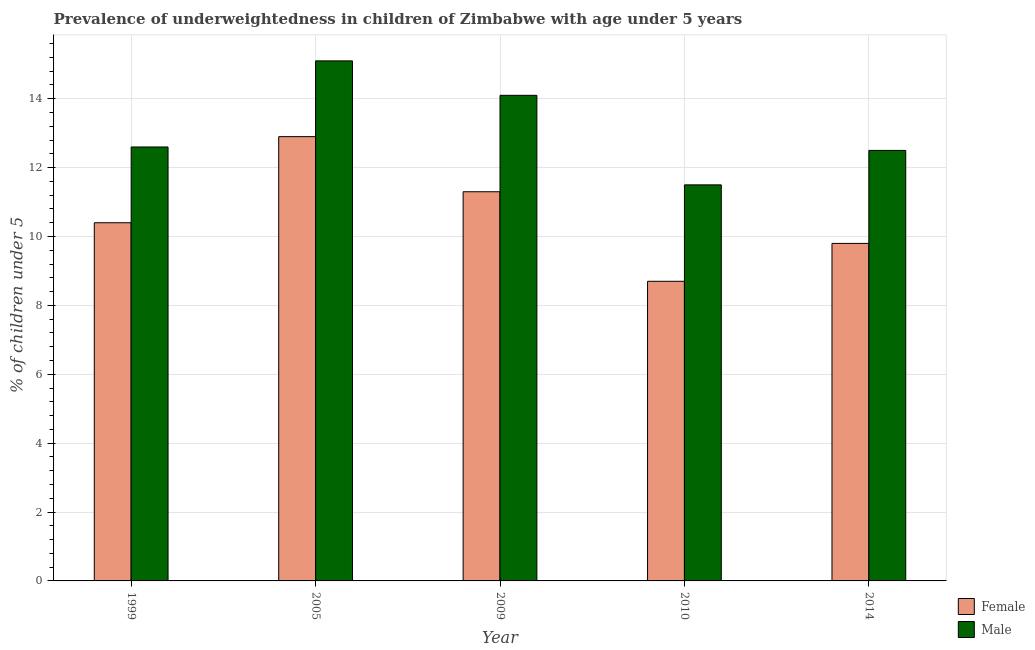Are the number of bars per tick equal to the number of legend labels?
Give a very brief answer. Yes. What is the label of the 3rd group of bars from the left?
Give a very brief answer. 2009. What is the percentage of underweighted female children in 2009?
Offer a very short reply. 11.3. Across all years, what is the maximum percentage of underweighted female children?
Offer a very short reply. 12.9. Across all years, what is the minimum percentage of underweighted female children?
Ensure brevity in your answer.  8.7. What is the total percentage of underweighted female children in the graph?
Make the answer very short. 53.1. What is the difference between the percentage of underweighted female children in 2005 and that in 2014?
Offer a very short reply. 3.1. What is the average percentage of underweighted female children per year?
Provide a short and direct response. 10.62. What is the ratio of the percentage of underweighted male children in 2009 to that in 2014?
Provide a succinct answer. 1.13. What is the difference between the highest and the lowest percentage of underweighted male children?
Your response must be concise. 3.6. In how many years, is the percentage of underweighted female children greater than the average percentage of underweighted female children taken over all years?
Keep it short and to the point. 2. Is the sum of the percentage of underweighted male children in 1999 and 2009 greater than the maximum percentage of underweighted female children across all years?
Make the answer very short. Yes. What does the 1st bar from the left in 1999 represents?
Ensure brevity in your answer.  Female. How many bars are there?
Your response must be concise. 10. Are all the bars in the graph horizontal?
Your answer should be compact. No. Does the graph contain grids?
Give a very brief answer. Yes. Where does the legend appear in the graph?
Ensure brevity in your answer.  Bottom right. How many legend labels are there?
Keep it short and to the point. 2. What is the title of the graph?
Provide a short and direct response. Prevalence of underweightedness in children of Zimbabwe with age under 5 years. What is the label or title of the Y-axis?
Offer a terse response.  % of children under 5. What is the  % of children under 5 of Female in 1999?
Provide a short and direct response. 10.4. What is the  % of children under 5 of Male in 1999?
Your response must be concise. 12.6. What is the  % of children under 5 of Female in 2005?
Keep it short and to the point. 12.9. What is the  % of children under 5 of Male in 2005?
Make the answer very short. 15.1. What is the  % of children under 5 in Female in 2009?
Provide a succinct answer. 11.3. What is the  % of children under 5 in Male in 2009?
Offer a very short reply. 14.1. What is the  % of children under 5 of Female in 2010?
Your answer should be compact. 8.7. What is the  % of children under 5 of Female in 2014?
Offer a terse response. 9.8. Across all years, what is the maximum  % of children under 5 in Female?
Provide a short and direct response. 12.9. Across all years, what is the maximum  % of children under 5 in Male?
Your response must be concise. 15.1. Across all years, what is the minimum  % of children under 5 of Female?
Give a very brief answer. 8.7. What is the total  % of children under 5 in Female in the graph?
Keep it short and to the point. 53.1. What is the total  % of children under 5 of Male in the graph?
Offer a very short reply. 65.8. What is the difference between the  % of children under 5 of Female in 1999 and that in 2005?
Your answer should be compact. -2.5. What is the difference between the  % of children under 5 in Male in 1999 and that in 2005?
Your answer should be very brief. -2.5. What is the difference between the  % of children under 5 in Female in 1999 and that in 2009?
Provide a succinct answer. -0.9. What is the difference between the  % of children under 5 of Male in 1999 and that in 2009?
Give a very brief answer. -1.5. What is the difference between the  % of children under 5 in Female in 1999 and that in 2014?
Ensure brevity in your answer.  0.6. What is the difference between the  % of children under 5 of Female in 2005 and that in 2009?
Provide a short and direct response. 1.6. What is the difference between the  % of children under 5 of Male in 2005 and that in 2009?
Your answer should be very brief. 1. What is the difference between the  % of children under 5 in Female in 2005 and that in 2010?
Your response must be concise. 4.2. What is the difference between the  % of children under 5 of Male in 2005 and that in 2010?
Offer a terse response. 3.6. What is the difference between the  % of children under 5 of Female in 2005 and that in 2014?
Give a very brief answer. 3.1. What is the difference between the  % of children under 5 in Male in 2005 and that in 2014?
Ensure brevity in your answer.  2.6. What is the difference between the  % of children under 5 in Female in 2009 and that in 2010?
Give a very brief answer. 2.6. What is the difference between the  % of children under 5 in Male in 2009 and that in 2010?
Ensure brevity in your answer.  2.6. What is the difference between the  % of children under 5 in Female in 2009 and that in 2014?
Offer a very short reply. 1.5. What is the difference between the  % of children under 5 in Male in 2009 and that in 2014?
Your answer should be very brief. 1.6. What is the difference between the  % of children under 5 of Male in 2010 and that in 2014?
Keep it short and to the point. -1. What is the difference between the  % of children under 5 in Female in 1999 and the  % of children under 5 in Male in 2005?
Offer a very short reply. -4.7. What is the difference between the  % of children under 5 in Female in 1999 and the  % of children under 5 in Male in 2010?
Offer a very short reply. -1.1. What is the difference between the  % of children under 5 in Female in 2005 and the  % of children under 5 in Male in 2010?
Your answer should be very brief. 1.4. What is the difference between the  % of children under 5 of Female in 2005 and the  % of children under 5 of Male in 2014?
Offer a very short reply. 0.4. What is the difference between the  % of children under 5 of Female in 2010 and the  % of children under 5 of Male in 2014?
Offer a very short reply. -3.8. What is the average  % of children under 5 in Female per year?
Offer a very short reply. 10.62. What is the average  % of children under 5 in Male per year?
Make the answer very short. 13.16. In the year 2005, what is the difference between the  % of children under 5 of Female and  % of children under 5 of Male?
Make the answer very short. -2.2. In the year 2009, what is the difference between the  % of children under 5 in Female and  % of children under 5 in Male?
Provide a short and direct response. -2.8. In the year 2010, what is the difference between the  % of children under 5 in Female and  % of children under 5 in Male?
Offer a very short reply. -2.8. In the year 2014, what is the difference between the  % of children under 5 of Female and  % of children under 5 of Male?
Provide a short and direct response. -2.7. What is the ratio of the  % of children under 5 in Female in 1999 to that in 2005?
Offer a terse response. 0.81. What is the ratio of the  % of children under 5 in Male in 1999 to that in 2005?
Offer a terse response. 0.83. What is the ratio of the  % of children under 5 of Female in 1999 to that in 2009?
Keep it short and to the point. 0.92. What is the ratio of the  % of children under 5 in Male in 1999 to that in 2009?
Keep it short and to the point. 0.89. What is the ratio of the  % of children under 5 of Female in 1999 to that in 2010?
Give a very brief answer. 1.2. What is the ratio of the  % of children under 5 of Male in 1999 to that in 2010?
Offer a terse response. 1.1. What is the ratio of the  % of children under 5 of Female in 1999 to that in 2014?
Offer a very short reply. 1.06. What is the ratio of the  % of children under 5 in Male in 1999 to that in 2014?
Offer a terse response. 1.01. What is the ratio of the  % of children under 5 in Female in 2005 to that in 2009?
Provide a short and direct response. 1.14. What is the ratio of the  % of children under 5 of Male in 2005 to that in 2009?
Ensure brevity in your answer.  1.07. What is the ratio of the  % of children under 5 of Female in 2005 to that in 2010?
Your answer should be compact. 1.48. What is the ratio of the  % of children under 5 of Male in 2005 to that in 2010?
Your answer should be very brief. 1.31. What is the ratio of the  % of children under 5 of Female in 2005 to that in 2014?
Give a very brief answer. 1.32. What is the ratio of the  % of children under 5 in Male in 2005 to that in 2014?
Keep it short and to the point. 1.21. What is the ratio of the  % of children under 5 of Female in 2009 to that in 2010?
Make the answer very short. 1.3. What is the ratio of the  % of children under 5 of Male in 2009 to that in 2010?
Ensure brevity in your answer.  1.23. What is the ratio of the  % of children under 5 of Female in 2009 to that in 2014?
Give a very brief answer. 1.15. What is the ratio of the  % of children under 5 of Male in 2009 to that in 2014?
Provide a short and direct response. 1.13. What is the ratio of the  % of children under 5 in Female in 2010 to that in 2014?
Offer a very short reply. 0.89. What is the ratio of the  % of children under 5 in Male in 2010 to that in 2014?
Keep it short and to the point. 0.92. What is the difference between the highest and the second highest  % of children under 5 of Male?
Your response must be concise. 1. What is the difference between the highest and the lowest  % of children under 5 in Male?
Give a very brief answer. 3.6. 